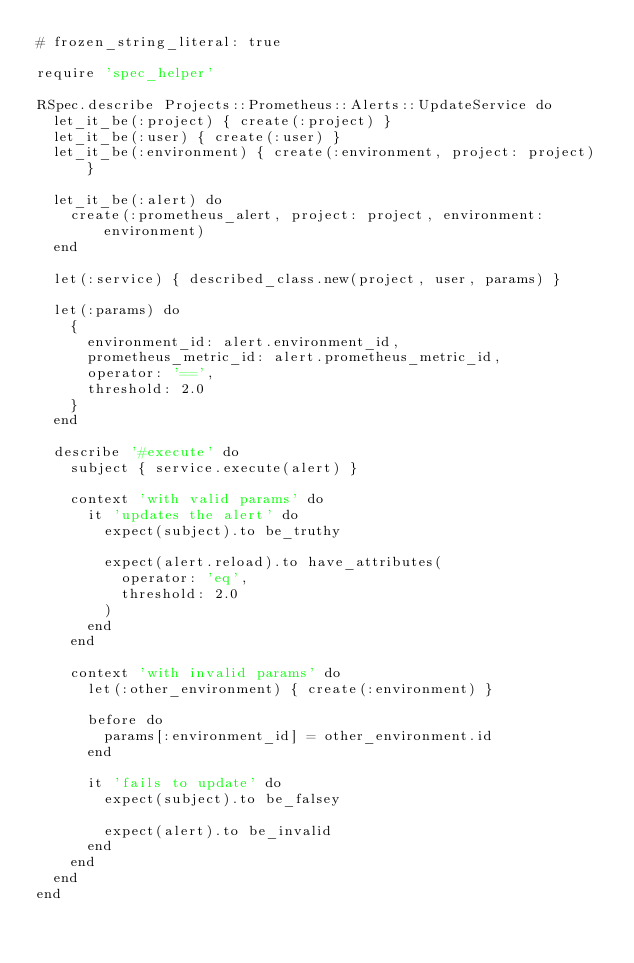<code> <loc_0><loc_0><loc_500><loc_500><_Ruby_># frozen_string_literal: true

require 'spec_helper'

RSpec.describe Projects::Prometheus::Alerts::UpdateService do
  let_it_be(:project) { create(:project) }
  let_it_be(:user) { create(:user) }
  let_it_be(:environment) { create(:environment, project: project) }

  let_it_be(:alert) do
    create(:prometheus_alert, project: project, environment: environment)
  end

  let(:service) { described_class.new(project, user, params) }

  let(:params) do
    {
      environment_id: alert.environment_id,
      prometheus_metric_id: alert.prometheus_metric_id,
      operator: '==',
      threshold: 2.0
    }
  end

  describe '#execute' do
    subject { service.execute(alert) }

    context 'with valid params' do
      it 'updates the alert' do
        expect(subject).to be_truthy

        expect(alert.reload).to have_attributes(
          operator: 'eq',
          threshold: 2.0
        )
      end
    end

    context 'with invalid params' do
      let(:other_environment) { create(:environment) }

      before do
        params[:environment_id] = other_environment.id
      end

      it 'fails to update' do
        expect(subject).to be_falsey

        expect(alert).to be_invalid
      end
    end
  end
end
</code> 